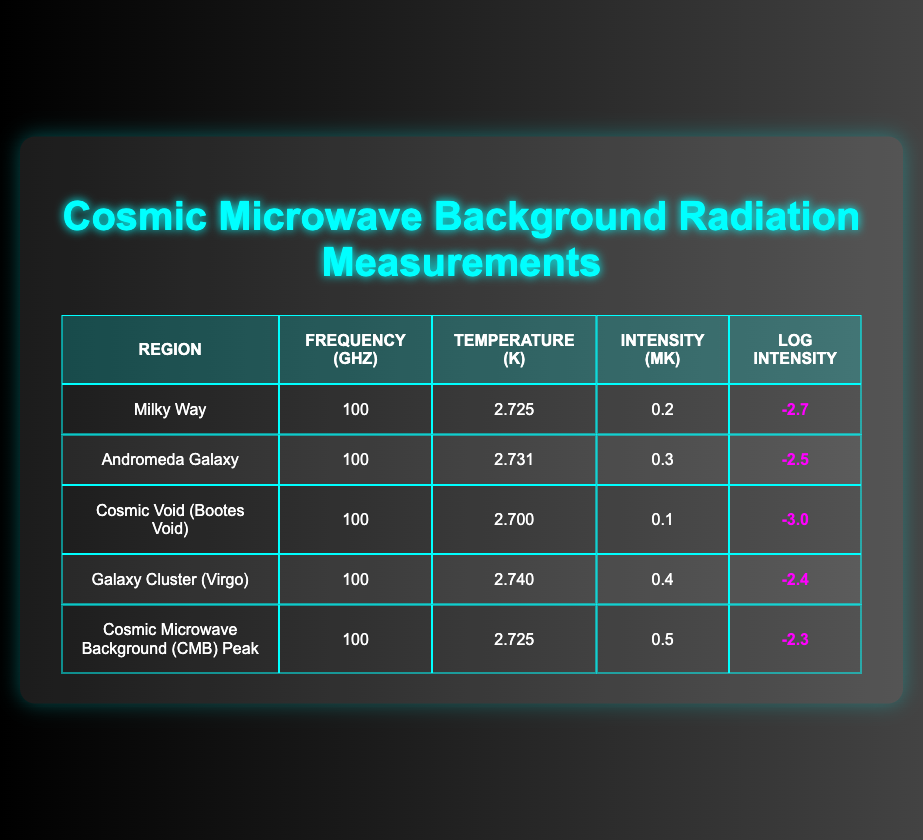What is the intensity measurement for the Andromeda Galaxy? The table indicates that the intensity measurement for the Andromeda Galaxy is 0.3 mK.
Answer: 0.3 mK Which region has the highest log intensity? By comparing the "Log Intensity" values in the table, the highest log intensity is -2.3, associated with the Cosmic Microwave Background (CMB) Peak.
Answer: -2.3 What is the average temperature of the measured regions? To find the average temperature, we sum the temperatures: (2.725 + 2.731 + 2.700 + 2.740 + 2.725) = 13.651. Then, divide by the number of regions (5): 13.651 / 5 = 2.7302 K.
Answer: 2.7302 K Is the intensity for the Cosmic Void greater than that of the Milky Way? The intensity for the Cosmic Void is 0.1 mK, while for the Milky Way it is 0.2 mK. Since 0.1 < 0.2, the statement is false.
Answer: No Which regions have an intensity higher than 0.25 mK? We find the regions with intensity values exceeding 0.25 mK in the table. The Andromeda Galaxy (0.3 mK) and Galaxy Cluster (Virgo) (0.4 mK) meet this criterion.
Answer: Andromeda Galaxy, Galaxy Cluster (Virgo) What is the difference in temperature between the Galaxy Cluster and the Cosmic Void? The temperature for the Galaxy Cluster is 2.740 K and for the Cosmic Void is 2.700 K. The difference is calculated as 2.740 - 2.700 = 0.040 K.
Answer: 0.040 K How many regions have a log intensity of less than -2.6? By checking the "Log Intensity" values, the regions with log intensity less than -2.6 are the Cosmic Void (-3.0) and the Cosmic Microwave Background Peak (-2.3). This gives a total of 3 regions (Cosmic Void, Milky Way, and CMB Peak).
Answer: 3 What is the frequency of the CMB Peak region? The CMB Peak region has a frequency of 100 GHz, as shown in the table.
Answer: 100 GHz 